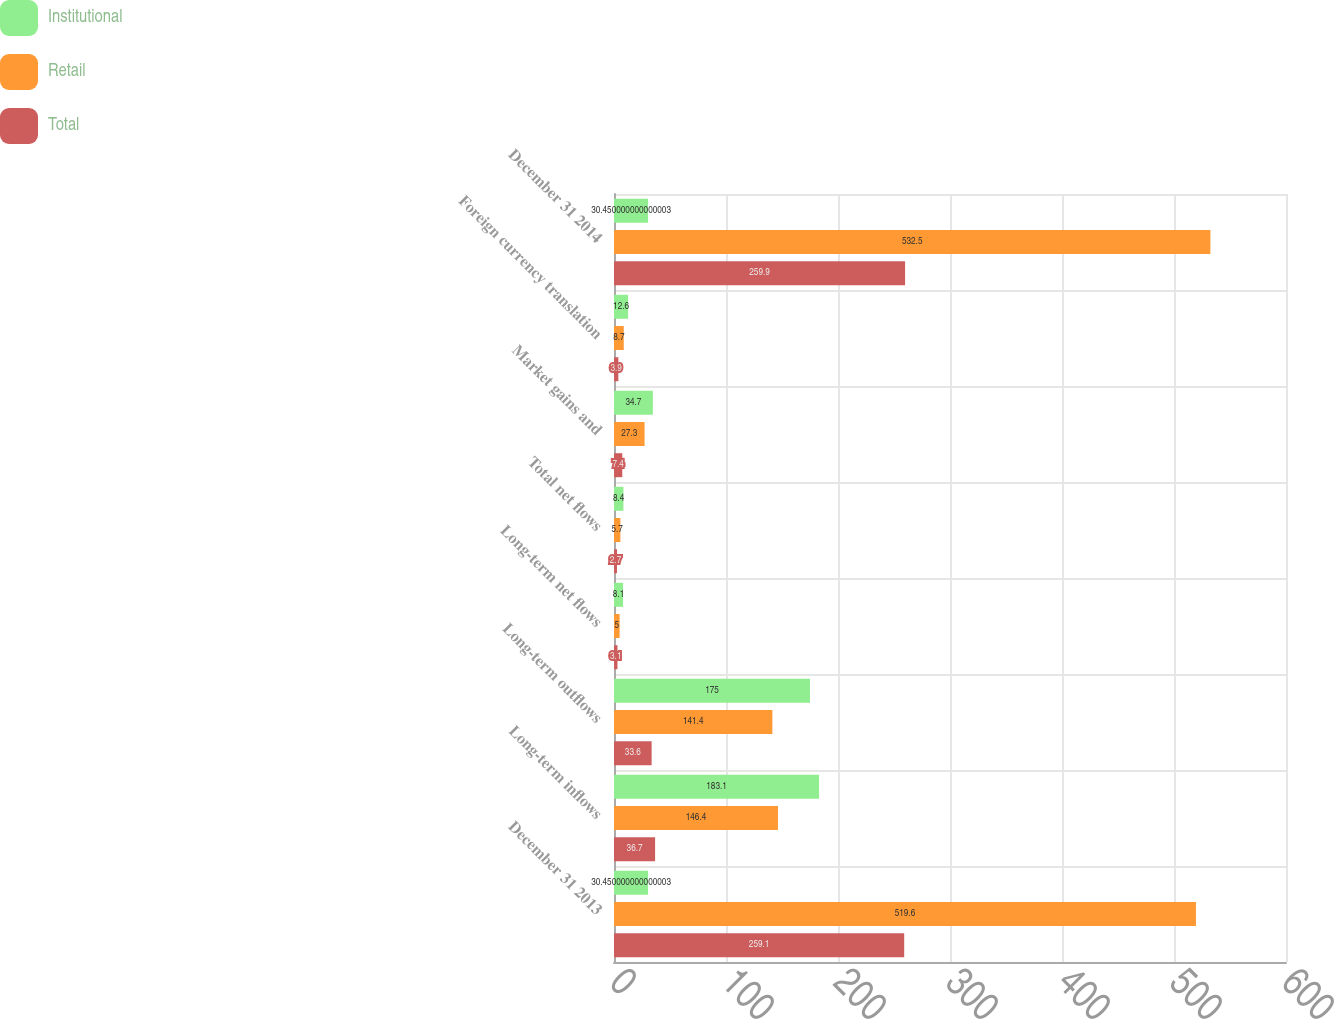Convert chart. <chart><loc_0><loc_0><loc_500><loc_500><stacked_bar_chart><ecel><fcel>December 31 2013<fcel>Long-term inflows<fcel>Long-term outflows<fcel>Long-term net flows<fcel>Total net flows<fcel>Market gains and<fcel>Foreign currency translation<fcel>December 31 2014<nl><fcel>Institutional<fcel>30.45<fcel>183.1<fcel>175<fcel>8.1<fcel>8.4<fcel>34.7<fcel>12.6<fcel>30.45<nl><fcel>Retail<fcel>519.6<fcel>146.4<fcel>141.4<fcel>5<fcel>5.7<fcel>27.3<fcel>8.7<fcel>532.5<nl><fcel>Total<fcel>259.1<fcel>36.7<fcel>33.6<fcel>3.1<fcel>2.7<fcel>7.4<fcel>3.9<fcel>259.9<nl></chart> 